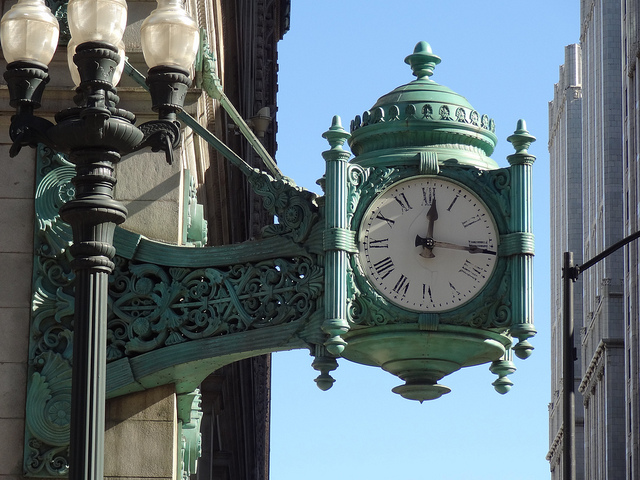Please identify all text content in this image. VIII 